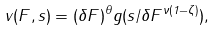Convert formula to latex. <formula><loc_0><loc_0><loc_500><loc_500>v ( F , s ) = ( \delta F ) ^ { \theta } g ( s / \delta F ^ { \nu ( 1 - \zeta ) } ) ,</formula> 